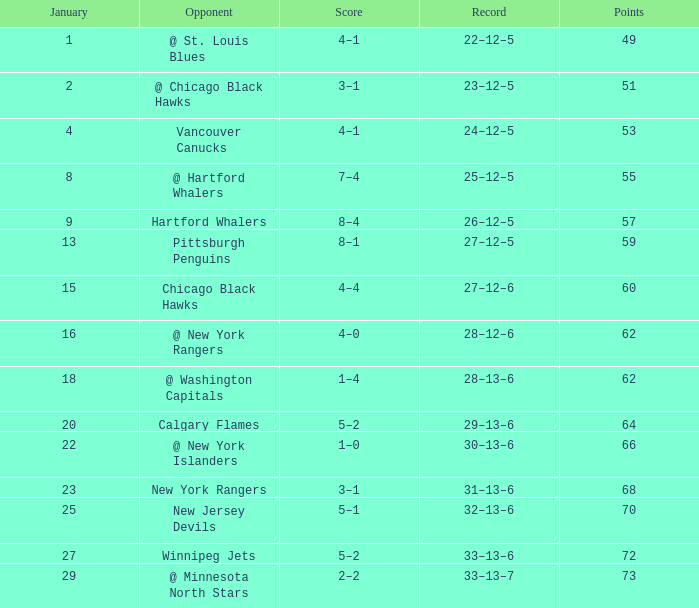Which points exhibit a score of 4-1 with a game that is under 39? None. 